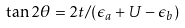<formula> <loc_0><loc_0><loc_500><loc_500>\tan 2 \theta = 2 t / ( \epsilon _ { a } + U - \epsilon _ { b } )</formula> 